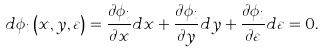Convert formula to latex. <formula><loc_0><loc_0><loc_500><loc_500>d \phi _ { i } \left ( { x , y , \varepsilon } \right ) = \frac { \partial \phi _ { i } } { \partial x } d x + \frac { \partial \phi _ { i } } { \partial y } d y + \frac { \partial \phi _ { i } } { \partial \varepsilon } d \varepsilon = 0 .</formula> 